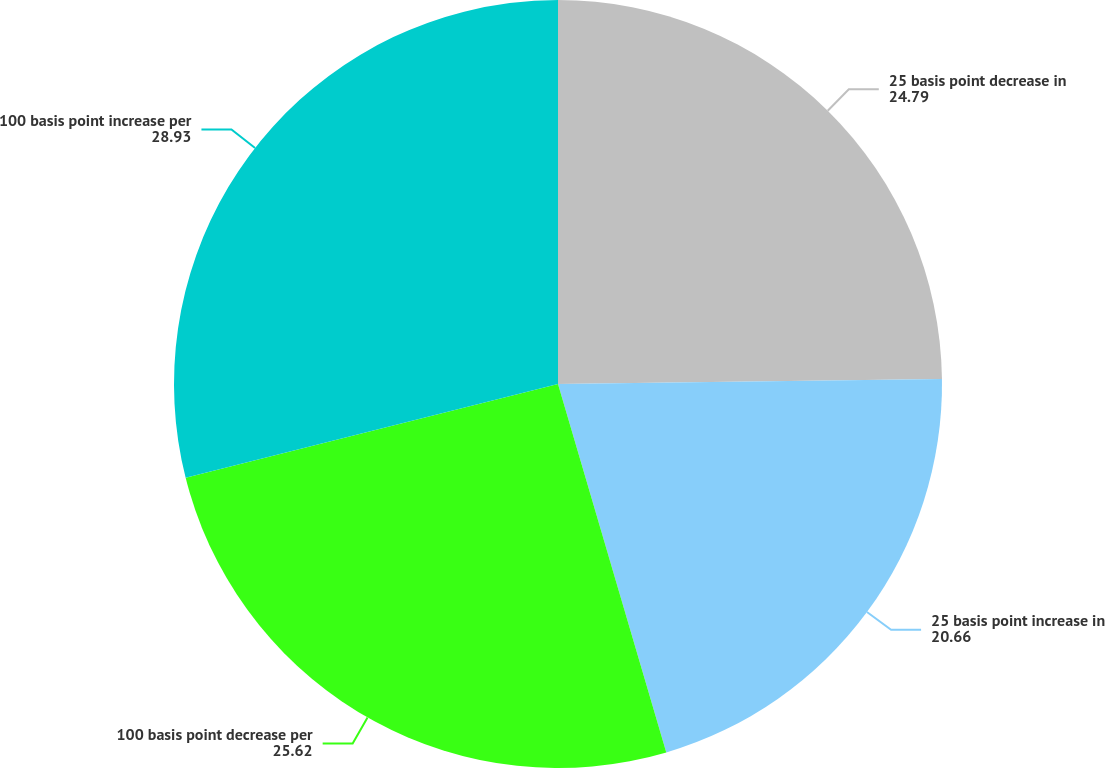Convert chart to OTSL. <chart><loc_0><loc_0><loc_500><loc_500><pie_chart><fcel>25 basis point decrease in<fcel>25 basis point increase in<fcel>100 basis point decrease per<fcel>100 basis point increase per<nl><fcel>24.79%<fcel>20.66%<fcel>25.62%<fcel>28.93%<nl></chart> 